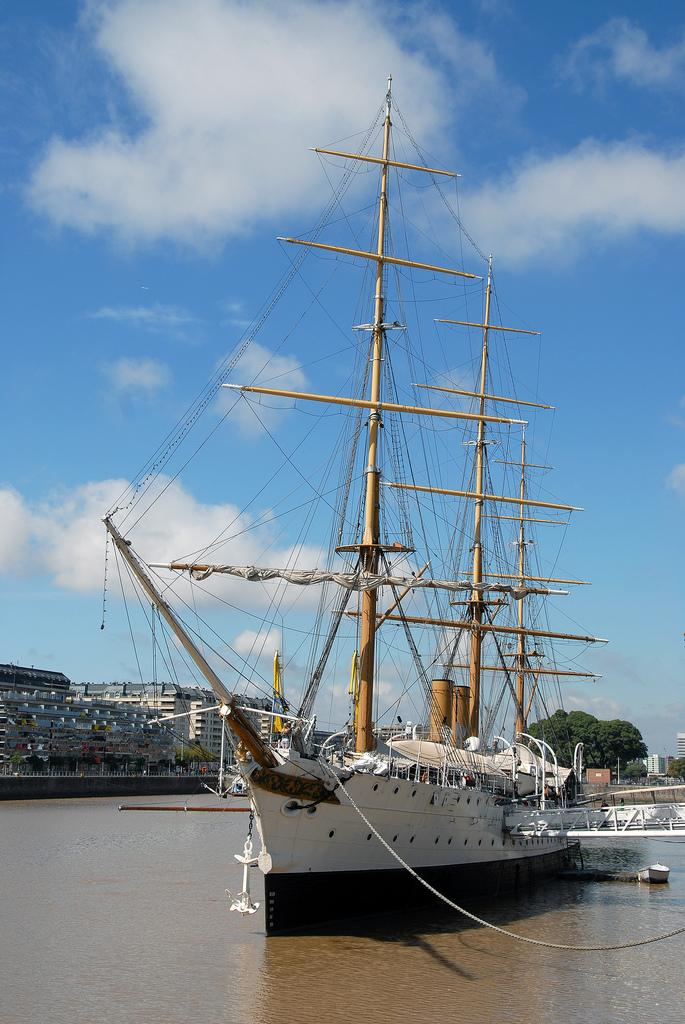What is the main subject of the image? There is a ship in the image. Where is the ship located? The ship is on the water. What can be seen in the background of the image? There are buildings and trees in the background of the image. What is visible at the top of the image? The sky is visible at the top of the image. What can be observed in the sky? Clouds are present in the sky. What type of fact can be seen in the image? There is no fact present in the image; it is a picture of a ship on the water with buildings, trees, and clouds in the background. What quartz formation can be observed near the ship in the image? There is no quartz formation present in the image. 